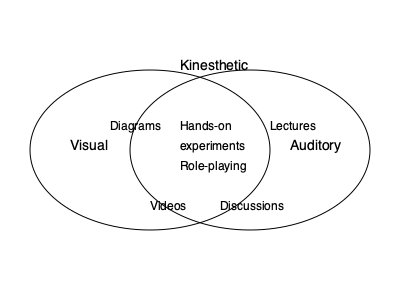Based on the Venn diagram showing learning styles and teaching methods, which teaching method would be most effective for a student who learns best through both visual and auditory means? To answer this question, let's analyze the Venn diagram step-by-step:

1. The diagram shows three learning styles: Visual, Auditory, and Kinesthetic.

2. Each circle represents a learning style, with the overlapping areas indicating teaching methods that cater to multiple styles.

3. We need to focus on the area where Visual and Auditory styles overlap.

4. In this overlapping area, we can see two teaching methods:
   a) Videos
   b) Discussions

5. Both of these methods incorporate visual and auditory elements:
   - Videos provide both visual stimuli and audio information.
   - Discussions involve listening to others (auditory) and often include visual cues from speakers or visual aids.

6. However, videos tend to be more structured and can consistently provide both visual and auditory information simultaneously, making them slightly more effective for combining these two learning styles.

Therefore, the most effective teaching method for a student who learns best through both visual and auditory means would be videos.
Answer: Videos 